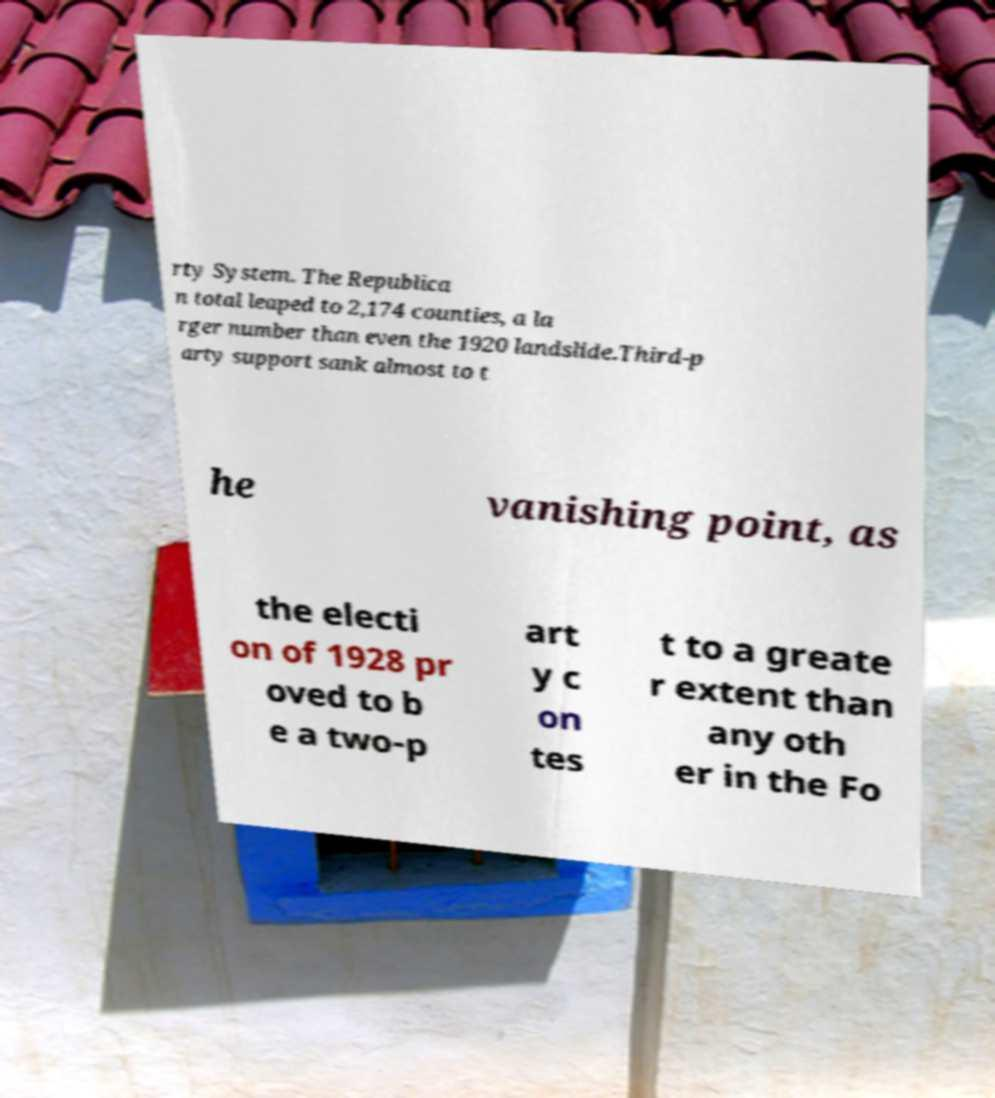I need the written content from this picture converted into text. Can you do that? rty System. The Republica n total leaped to 2,174 counties, a la rger number than even the 1920 landslide.Third-p arty support sank almost to t he vanishing point, as the electi on of 1928 pr oved to b e a two-p art y c on tes t to a greate r extent than any oth er in the Fo 